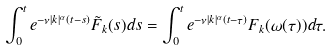<formula> <loc_0><loc_0><loc_500><loc_500>\int _ { 0 } ^ { t } e ^ { - \nu | k | ^ { \alpha } ( t - s ) } \tilde { F } _ { k } ( s ) d s = \int _ { 0 } ^ { t } e ^ { - \nu | k | ^ { \alpha } ( t - \tau ) } F _ { k } ( \omega ( \tau ) ) d \tau .</formula> 